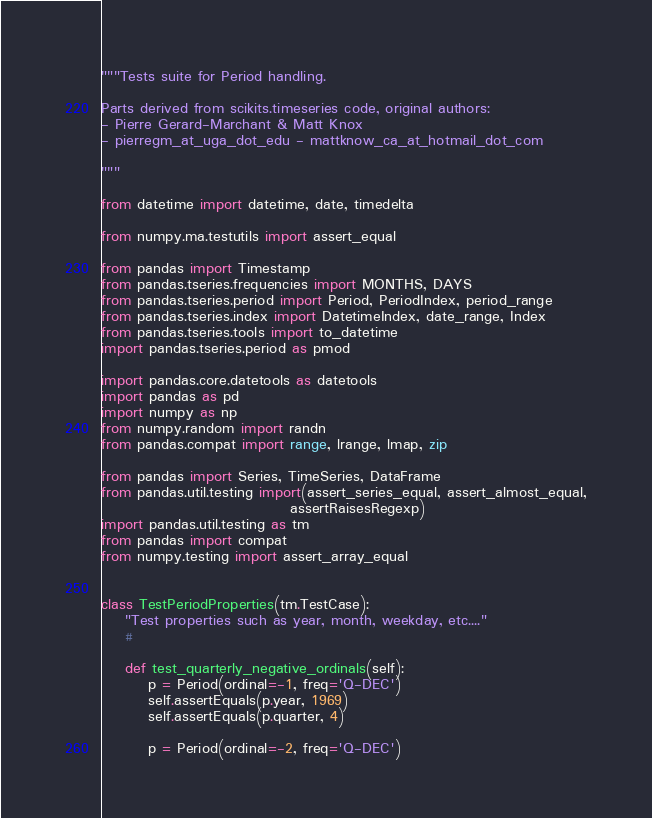<code> <loc_0><loc_0><loc_500><loc_500><_Python_>"""Tests suite for Period handling.

Parts derived from scikits.timeseries code, original authors:
- Pierre Gerard-Marchant & Matt Knox
- pierregm_at_uga_dot_edu - mattknow_ca_at_hotmail_dot_com

"""

from datetime import datetime, date, timedelta

from numpy.ma.testutils import assert_equal

from pandas import Timestamp
from pandas.tseries.frequencies import MONTHS, DAYS
from pandas.tseries.period import Period, PeriodIndex, period_range
from pandas.tseries.index import DatetimeIndex, date_range, Index
from pandas.tseries.tools import to_datetime
import pandas.tseries.period as pmod

import pandas.core.datetools as datetools
import pandas as pd
import numpy as np
from numpy.random import randn
from pandas.compat import range, lrange, lmap, zip

from pandas import Series, TimeSeries, DataFrame
from pandas.util.testing import(assert_series_equal, assert_almost_equal,
                                assertRaisesRegexp)
import pandas.util.testing as tm
from pandas import compat
from numpy.testing import assert_array_equal


class TestPeriodProperties(tm.TestCase):
    "Test properties such as year, month, weekday, etc...."
    #

    def test_quarterly_negative_ordinals(self):
        p = Period(ordinal=-1, freq='Q-DEC')
        self.assertEquals(p.year, 1969)
        self.assertEquals(p.quarter, 4)

        p = Period(ordinal=-2, freq='Q-DEC')</code> 